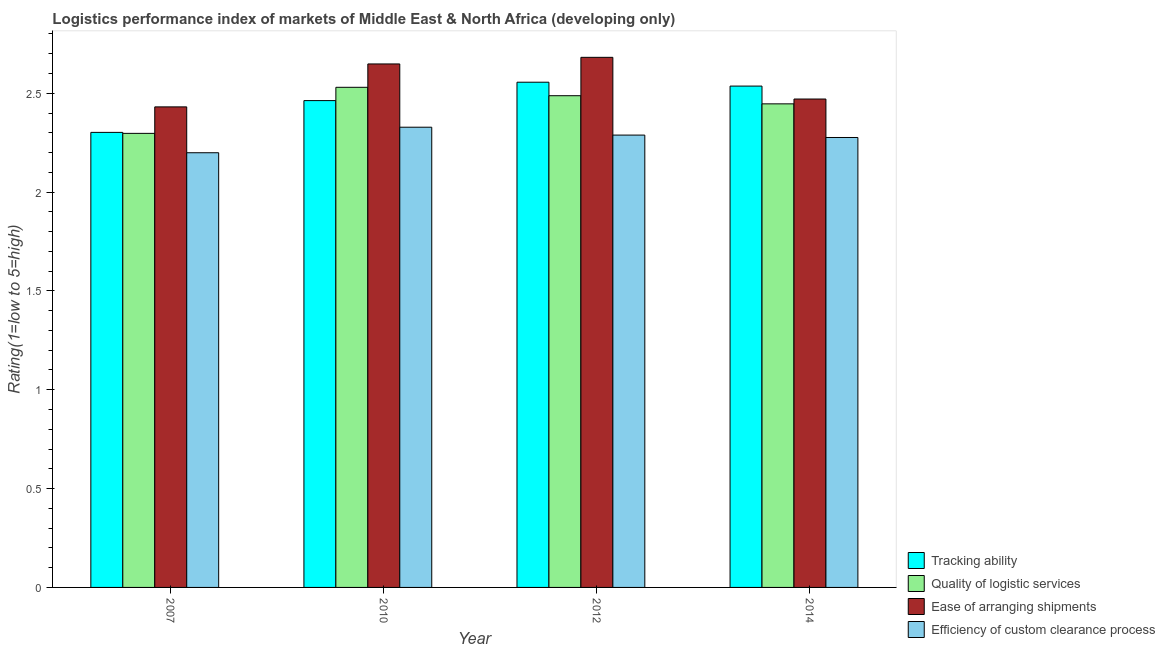How many different coloured bars are there?
Provide a succinct answer. 4. Are the number of bars per tick equal to the number of legend labels?
Provide a short and direct response. Yes. Are the number of bars on each tick of the X-axis equal?
Your response must be concise. Yes. In how many cases, is the number of bars for a given year not equal to the number of legend labels?
Your response must be concise. 0. What is the lpi rating of tracking ability in 2007?
Provide a succinct answer. 2.3. Across all years, what is the maximum lpi rating of efficiency of custom clearance process?
Keep it short and to the point. 2.33. Across all years, what is the minimum lpi rating of efficiency of custom clearance process?
Your response must be concise. 2.2. In which year was the lpi rating of efficiency of custom clearance process minimum?
Your response must be concise. 2007. What is the total lpi rating of ease of arranging shipments in the graph?
Provide a short and direct response. 10.23. What is the difference between the lpi rating of tracking ability in 2010 and that in 2014?
Your answer should be very brief. -0.07. What is the difference between the lpi rating of quality of logistic services in 2012 and the lpi rating of efficiency of custom clearance process in 2010?
Your answer should be very brief. -0.04. What is the average lpi rating of ease of arranging shipments per year?
Offer a very short reply. 2.56. In how many years, is the lpi rating of ease of arranging shipments greater than 0.7?
Your response must be concise. 4. What is the ratio of the lpi rating of quality of logistic services in 2007 to that in 2012?
Ensure brevity in your answer.  0.92. Is the lpi rating of tracking ability in 2012 less than that in 2014?
Provide a succinct answer. No. What is the difference between the highest and the second highest lpi rating of efficiency of custom clearance process?
Keep it short and to the point. 0.04. What is the difference between the highest and the lowest lpi rating of quality of logistic services?
Provide a short and direct response. 0.23. In how many years, is the lpi rating of ease of arranging shipments greater than the average lpi rating of ease of arranging shipments taken over all years?
Offer a very short reply. 2. Is the sum of the lpi rating of ease of arranging shipments in 2007 and 2010 greater than the maximum lpi rating of efficiency of custom clearance process across all years?
Offer a very short reply. Yes. What does the 3rd bar from the left in 2010 represents?
Your response must be concise. Ease of arranging shipments. What does the 3rd bar from the right in 2007 represents?
Offer a terse response. Quality of logistic services. How many bars are there?
Your answer should be very brief. 16. Are all the bars in the graph horizontal?
Your answer should be very brief. No. How many years are there in the graph?
Provide a short and direct response. 4. What is the difference between two consecutive major ticks on the Y-axis?
Ensure brevity in your answer.  0.5. Does the graph contain any zero values?
Your response must be concise. No. Does the graph contain grids?
Your response must be concise. No. How many legend labels are there?
Offer a terse response. 4. How are the legend labels stacked?
Ensure brevity in your answer.  Vertical. What is the title of the graph?
Keep it short and to the point. Logistics performance index of markets of Middle East & North Africa (developing only). Does "Secondary general" appear as one of the legend labels in the graph?
Make the answer very short. No. What is the label or title of the X-axis?
Offer a terse response. Year. What is the label or title of the Y-axis?
Offer a very short reply. Rating(1=low to 5=high). What is the Rating(1=low to 5=high) in Tracking ability in 2007?
Offer a terse response. 2.3. What is the Rating(1=low to 5=high) of Quality of logistic services in 2007?
Give a very brief answer. 2.3. What is the Rating(1=low to 5=high) in Ease of arranging shipments in 2007?
Ensure brevity in your answer.  2.43. What is the Rating(1=low to 5=high) of Efficiency of custom clearance process in 2007?
Offer a very short reply. 2.2. What is the Rating(1=low to 5=high) in Tracking ability in 2010?
Your response must be concise. 2.46. What is the Rating(1=low to 5=high) of Quality of logistic services in 2010?
Your answer should be very brief. 2.53. What is the Rating(1=low to 5=high) in Ease of arranging shipments in 2010?
Offer a very short reply. 2.65. What is the Rating(1=low to 5=high) in Efficiency of custom clearance process in 2010?
Your response must be concise. 2.33. What is the Rating(1=low to 5=high) in Tracking ability in 2012?
Your answer should be very brief. 2.56. What is the Rating(1=low to 5=high) of Quality of logistic services in 2012?
Offer a very short reply. 2.49. What is the Rating(1=low to 5=high) of Ease of arranging shipments in 2012?
Ensure brevity in your answer.  2.68. What is the Rating(1=low to 5=high) in Efficiency of custom clearance process in 2012?
Keep it short and to the point. 2.29. What is the Rating(1=low to 5=high) of Tracking ability in 2014?
Provide a succinct answer. 2.54. What is the Rating(1=low to 5=high) in Quality of logistic services in 2014?
Your response must be concise. 2.45. What is the Rating(1=low to 5=high) of Ease of arranging shipments in 2014?
Offer a terse response. 2.47. What is the Rating(1=low to 5=high) of Efficiency of custom clearance process in 2014?
Your answer should be very brief. 2.28. Across all years, what is the maximum Rating(1=low to 5=high) of Tracking ability?
Offer a very short reply. 2.56. Across all years, what is the maximum Rating(1=low to 5=high) in Quality of logistic services?
Your answer should be compact. 2.53. Across all years, what is the maximum Rating(1=low to 5=high) of Ease of arranging shipments?
Keep it short and to the point. 2.68. Across all years, what is the maximum Rating(1=low to 5=high) of Efficiency of custom clearance process?
Offer a terse response. 2.33. Across all years, what is the minimum Rating(1=low to 5=high) in Tracking ability?
Make the answer very short. 2.3. Across all years, what is the minimum Rating(1=low to 5=high) of Quality of logistic services?
Offer a terse response. 2.3. Across all years, what is the minimum Rating(1=low to 5=high) in Ease of arranging shipments?
Make the answer very short. 2.43. Across all years, what is the minimum Rating(1=low to 5=high) of Efficiency of custom clearance process?
Provide a short and direct response. 2.2. What is the total Rating(1=low to 5=high) in Tracking ability in the graph?
Give a very brief answer. 9.86. What is the total Rating(1=low to 5=high) in Quality of logistic services in the graph?
Keep it short and to the point. 9.76. What is the total Rating(1=low to 5=high) of Ease of arranging shipments in the graph?
Keep it short and to the point. 10.23. What is the total Rating(1=low to 5=high) of Efficiency of custom clearance process in the graph?
Provide a succinct answer. 9.09. What is the difference between the Rating(1=low to 5=high) of Tracking ability in 2007 and that in 2010?
Your response must be concise. -0.16. What is the difference between the Rating(1=low to 5=high) in Quality of logistic services in 2007 and that in 2010?
Provide a succinct answer. -0.23. What is the difference between the Rating(1=low to 5=high) of Ease of arranging shipments in 2007 and that in 2010?
Ensure brevity in your answer.  -0.22. What is the difference between the Rating(1=low to 5=high) of Efficiency of custom clearance process in 2007 and that in 2010?
Provide a succinct answer. -0.13. What is the difference between the Rating(1=low to 5=high) of Tracking ability in 2007 and that in 2012?
Provide a short and direct response. -0.25. What is the difference between the Rating(1=low to 5=high) in Quality of logistic services in 2007 and that in 2012?
Your answer should be very brief. -0.19. What is the difference between the Rating(1=low to 5=high) of Ease of arranging shipments in 2007 and that in 2012?
Your answer should be very brief. -0.25. What is the difference between the Rating(1=low to 5=high) of Efficiency of custom clearance process in 2007 and that in 2012?
Your response must be concise. -0.09. What is the difference between the Rating(1=low to 5=high) in Tracking ability in 2007 and that in 2014?
Your answer should be very brief. -0.23. What is the difference between the Rating(1=low to 5=high) of Quality of logistic services in 2007 and that in 2014?
Make the answer very short. -0.15. What is the difference between the Rating(1=low to 5=high) in Ease of arranging shipments in 2007 and that in 2014?
Keep it short and to the point. -0.04. What is the difference between the Rating(1=low to 5=high) in Efficiency of custom clearance process in 2007 and that in 2014?
Your response must be concise. -0.08. What is the difference between the Rating(1=low to 5=high) of Tracking ability in 2010 and that in 2012?
Keep it short and to the point. -0.09. What is the difference between the Rating(1=low to 5=high) of Quality of logistic services in 2010 and that in 2012?
Your response must be concise. 0.04. What is the difference between the Rating(1=low to 5=high) of Ease of arranging shipments in 2010 and that in 2012?
Give a very brief answer. -0.03. What is the difference between the Rating(1=low to 5=high) in Efficiency of custom clearance process in 2010 and that in 2012?
Give a very brief answer. 0.04. What is the difference between the Rating(1=low to 5=high) in Tracking ability in 2010 and that in 2014?
Your answer should be compact. -0.07. What is the difference between the Rating(1=low to 5=high) in Quality of logistic services in 2010 and that in 2014?
Offer a very short reply. 0.08. What is the difference between the Rating(1=low to 5=high) of Ease of arranging shipments in 2010 and that in 2014?
Provide a succinct answer. 0.18. What is the difference between the Rating(1=low to 5=high) in Efficiency of custom clearance process in 2010 and that in 2014?
Make the answer very short. 0.05. What is the difference between the Rating(1=low to 5=high) of Tracking ability in 2012 and that in 2014?
Make the answer very short. 0.02. What is the difference between the Rating(1=low to 5=high) of Quality of logistic services in 2012 and that in 2014?
Give a very brief answer. 0.04. What is the difference between the Rating(1=low to 5=high) of Ease of arranging shipments in 2012 and that in 2014?
Give a very brief answer. 0.21. What is the difference between the Rating(1=low to 5=high) in Efficiency of custom clearance process in 2012 and that in 2014?
Your answer should be compact. 0.01. What is the difference between the Rating(1=low to 5=high) of Tracking ability in 2007 and the Rating(1=low to 5=high) of Quality of logistic services in 2010?
Make the answer very short. -0.23. What is the difference between the Rating(1=low to 5=high) in Tracking ability in 2007 and the Rating(1=low to 5=high) in Ease of arranging shipments in 2010?
Offer a very short reply. -0.35. What is the difference between the Rating(1=low to 5=high) in Tracking ability in 2007 and the Rating(1=low to 5=high) in Efficiency of custom clearance process in 2010?
Give a very brief answer. -0.03. What is the difference between the Rating(1=low to 5=high) in Quality of logistic services in 2007 and the Rating(1=low to 5=high) in Ease of arranging shipments in 2010?
Offer a terse response. -0.35. What is the difference between the Rating(1=low to 5=high) of Quality of logistic services in 2007 and the Rating(1=low to 5=high) of Efficiency of custom clearance process in 2010?
Ensure brevity in your answer.  -0.03. What is the difference between the Rating(1=low to 5=high) in Ease of arranging shipments in 2007 and the Rating(1=low to 5=high) in Efficiency of custom clearance process in 2010?
Give a very brief answer. 0.1. What is the difference between the Rating(1=low to 5=high) of Tracking ability in 2007 and the Rating(1=low to 5=high) of Quality of logistic services in 2012?
Ensure brevity in your answer.  -0.19. What is the difference between the Rating(1=low to 5=high) in Tracking ability in 2007 and the Rating(1=low to 5=high) in Ease of arranging shipments in 2012?
Your answer should be compact. -0.38. What is the difference between the Rating(1=low to 5=high) in Tracking ability in 2007 and the Rating(1=low to 5=high) in Efficiency of custom clearance process in 2012?
Offer a terse response. 0.01. What is the difference between the Rating(1=low to 5=high) in Quality of logistic services in 2007 and the Rating(1=low to 5=high) in Ease of arranging shipments in 2012?
Keep it short and to the point. -0.38. What is the difference between the Rating(1=low to 5=high) in Quality of logistic services in 2007 and the Rating(1=low to 5=high) in Efficiency of custom clearance process in 2012?
Offer a terse response. 0.01. What is the difference between the Rating(1=low to 5=high) of Ease of arranging shipments in 2007 and the Rating(1=low to 5=high) of Efficiency of custom clearance process in 2012?
Provide a succinct answer. 0.14. What is the difference between the Rating(1=low to 5=high) of Tracking ability in 2007 and the Rating(1=low to 5=high) of Quality of logistic services in 2014?
Make the answer very short. -0.14. What is the difference between the Rating(1=low to 5=high) of Tracking ability in 2007 and the Rating(1=low to 5=high) of Ease of arranging shipments in 2014?
Offer a very short reply. -0.17. What is the difference between the Rating(1=low to 5=high) of Tracking ability in 2007 and the Rating(1=low to 5=high) of Efficiency of custom clearance process in 2014?
Your answer should be very brief. 0.03. What is the difference between the Rating(1=low to 5=high) in Quality of logistic services in 2007 and the Rating(1=low to 5=high) in Ease of arranging shipments in 2014?
Your answer should be very brief. -0.17. What is the difference between the Rating(1=low to 5=high) in Quality of logistic services in 2007 and the Rating(1=low to 5=high) in Efficiency of custom clearance process in 2014?
Offer a terse response. 0.02. What is the difference between the Rating(1=low to 5=high) of Ease of arranging shipments in 2007 and the Rating(1=low to 5=high) of Efficiency of custom clearance process in 2014?
Give a very brief answer. 0.15. What is the difference between the Rating(1=low to 5=high) of Tracking ability in 2010 and the Rating(1=low to 5=high) of Quality of logistic services in 2012?
Make the answer very short. -0.02. What is the difference between the Rating(1=low to 5=high) in Tracking ability in 2010 and the Rating(1=low to 5=high) in Ease of arranging shipments in 2012?
Offer a very short reply. -0.22. What is the difference between the Rating(1=low to 5=high) of Tracking ability in 2010 and the Rating(1=low to 5=high) of Efficiency of custom clearance process in 2012?
Your answer should be very brief. 0.17. What is the difference between the Rating(1=low to 5=high) of Quality of logistic services in 2010 and the Rating(1=low to 5=high) of Ease of arranging shipments in 2012?
Give a very brief answer. -0.15. What is the difference between the Rating(1=low to 5=high) of Quality of logistic services in 2010 and the Rating(1=low to 5=high) of Efficiency of custom clearance process in 2012?
Provide a succinct answer. 0.24. What is the difference between the Rating(1=low to 5=high) of Ease of arranging shipments in 2010 and the Rating(1=low to 5=high) of Efficiency of custom clearance process in 2012?
Keep it short and to the point. 0.36. What is the difference between the Rating(1=low to 5=high) of Tracking ability in 2010 and the Rating(1=low to 5=high) of Quality of logistic services in 2014?
Your answer should be very brief. 0.02. What is the difference between the Rating(1=low to 5=high) of Tracking ability in 2010 and the Rating(1=low to 5=high) of Ease of arranging shipments in 2014?
Provide a succinct answer. -0.01. What is the difference between the Rating(1=low to 5=high) of Tracking ability in 2010 and the Rating(1=low to 5=high) of Efficiency of custom clearance process in 2014?
Offer a very short reply. 0.19. What is the difference between the Rating(1=low to 5=high) in Quality of logistic services in 2010 and the Rating(1=low to 5=high) in Ease of arranging shipments in 2014?
Keep it short and to the point. 0.06. What is the difference between the Rating(1=low to 5=high) in Quality of logistic services in 2010 and the Rating(1=low to 5=high) in Efficiency of custom clearance process in 2014?
Ensure brevity in your answer.  0.25. What is the difference between the Rating(1=low to 5=high) of Ease of arranging shipments in 2010 and the Rating(1=low to 5=high) of Efficiency of custom clearance process in 2014?
Make the answer very short. 0.37. What is the difference between the Rating(1=low to 5=high) in Tracking ability in 2012 and the Rating(1=low to 5=high) in Quality of logistic services in 2014?
Give a very brief answer. 0.11. What is the difference between the Rating(1=low to 5=high) of Tracking ability in 2012 and the Rating(1=low to 5=high) of Ease of arranging shipments in 2014?
Your answer should be compact. 0.09. What is the difference between the Rating(1=low to 5=high) of Tracking ability in 2012 and the Rating(1=low to 5=high) of Efficiency of custom clearance process in 2014?
Offer a very short reply. 0.28. What is the difference between the Rating(1=low to 5=high) in Quality of logistic services in 2012 and the Rating(1=low to 5=high) in Ease of arranging shipments in 2014?
Make the answer very short. 0.02. What is the difference between the Rating(1=low to 5=high) in Quality of logistic services in 2012 and the Rating(1=low to 5=high) in Efficiency of custom clearance process in 2014?
Make the answer very short. 0.21. What is the difference between the Rating(1=low to 5=high) of Ease of arranging shipments in 2012 and the Rating(1=low to 5=high) of Efficiency of custom clearance process in 2014?
Make the answer very short. 0.41. What is the average Rating(1=low to 5=high) of Tracking ability per year?
Offer a terse response. 2.46. What is the average Rating(1=low to 5=high) in Quality of logistic services per year?
Your answer should be compact. 2.44. What is the average Rating(1=low to 5=high) of Ease of arranging shipments per year?
Provide a short and direct response. 2.56. What is the average Rating(1=low to 5=high) of Efficiency of custom clearance process per year?
Provide a short and direct response. 2.27. In the year 2007, what is the difference between the Rating(1=low to 5=high) in Tracking ability and Rating(1=low to 5=high) in Quality of logistic services?
Offer a very short reply. 0.01. In the year 2007, what is the difference between the Rating(1=low to 5=high) in Tracking ability and Rating(1=low to 5=high) in Ease of arranging shipments?
Your response must be concise. -0.13. In the year 2007, what is the difference between the Rating(1=low to 5=high) in Tracking ability and Rating(1=low to 5=high) in Efficiency of custom clearance process?
Ensure brevity in your answer.  0.1. In the year 2007, what is the difference between the Rating(1=low to 5=high) of Quality of logistic services and Rating(1=low to 5=high) of Ease of arranging shipments?
Provide a succinct answer. -0.13. In the year 2007, what is the difference between the Rating(1=low to 5=high) of Quality of logistic services and Rating(1=low to 5=high) of Efficiency of custom clearance process?
Your answer should be compact. 0.1. In the year 2007, what is the difference between the Rating(1=low to 5=high) in Ease of arranging shipments and Rating(1=low to 5=high) in Efficiency of custom clearance process?
Offer a terse response. 0.23. In the year 2010, what is the difference between the Rating(1=low to 5=high) in Tracking ability and Rating(1=low to 5=high) in Quality of logistic services?
Give a very brief answer. -0.07. In the year 2010, what is the difference between the Rating(1=low to 5=high) in Tracking ability and Rating(1=low to 5=high) in Ease of arranging shipments?
Make the answer very short. -0.19. In the year 2010, what is the difference between the Rating(1=low to 5=high) of Tracking ability and Rating(1=low to 5=high) of Efficiency of custom clearance process?
Provide a short and direct response. 0.13. In the year 2010, what is the difference between the Rating(1=low to 5=high) in Quality of logistic services and Rating(1=low to 5=high) in Ease of arranging shipments?
Ensure brevity in your answer.  -0.12. In the year 2010, what is the difference between the Rating(1=low to 5=high) in Quality of logistic services and Rating(1=low to 5=high) in Efficiency of custom clearance process?
Your answer should be compact. 0.2. In the year 2010, what is the difference between the Rating(1=low to 5=high) of Ease of arranging shipments and Rating(1=low to 5=high) of Efficiency of custom clearance process?
Make the answer very short. 0.32. In the year 2012, what is the difference between the Rating(1=low to 5=high) of Tracking ability and Rating(1=low to 5=high) of Quality of logistic services?
Keep it short and to the point. 0.07. In the year 2012, what is the difference between the Rating(1=low to 5=high) of Tracking ability and Rating(1=low to 5=high) of Ease of arranging shipments?
Keep it short and to the point. -0.13. In the year 2012, what is the difference between the Rating(1=low to 5=high) of Tracking ability and Rating(1=low to 5=high) of Efficiency of custom clearance process?
Give a very brief answer. 0.27. In the year 2012, what is the difference between the Rating(1=low to 5=high) in Quality of logistic services and Rating(1=low to 5=high) in Ease of arranging shipments?
Ensure brevity in your answer.  -0.19. In the year 2012, what is the difference between the Rating(1=low to 5=high) in Quality of logistic services and Rating(1=low to 5=high) in Efficiency of custom clearance process?
Give a very brief answer. 0.2. In the year 2012, what is the difference between the Rating(1=low to 5=high) of Ease of arranging shipments and Rating(1=low to 5=high) of Efficiency of custom clearance process?
Your answer should be very brief. 0.39. In the year 2014, what is the difference between the Rating(1=low to 5=high) in Tracking ability and Rating(1=low to 5=high) in Quality of logistic services?
Offer a terse response. 0.09. In the year 2014, what is the difference between the Rating(1=low to 5=high) of Tracking ability and Rating(1=low to 5=high) of Ease of arranging shipments?
Your response must be concise. 0.07. In the year 2014, what is the difference between the Rating(1=low to 5=high) in Tracking ability and Rating(1=low to 5=high) in Efficiency of custom clearance process?
Offer a very short reply. 0.26. In the year 2014, what is the difference between the Rating(1=low to 5=high) of Quality of logistic services and Rating(1=low to 5=high) of Ease of arranging shipments?
Provide a succinct answer. -0.02. In the year 2014, what is the difference between the Rating(1=low to 5=high) in Quality of logistic services and Rating(1=low to 5=high) in Efficiency of custom clearance process?
Your answer should be very brief. 0.17. In the year 2014, what is the difference between the Rating(1=low to 5=high) in Ease of arranging shipments and Rating(1=low to 5=high) in Efficiency of custom clearance process?
Ensure brevity in your answer.  0.19. What is the ratio of the Rating(1=low to 5=high) of Tracking ability in 2007 to that in 2010?
Make the answer very short. 0.93. What is the ratio of the Rating(1=low to 5=high) of Quality of logistic services in 2007 to that in 2010?
Offer a very short reply. 0.91. What is the ratio of the Rating(1=low to 5=high) in Ease of arranging shipments in 2007 to that in 2010?
Give a very brief answer. 0.92. What is the ratio of the Rating(1=low to 5=high) in Efficiency of custom clearance process in 2007 to that in 2010?
Ensure brevity in your answer.  0.94. What is the ratio of the Rating(1=low to 5=high) of Tracking ability in 2007 to that in 2012?
Your response must be concise. 0.9. What is the ratio of the Rating(1=low to 5=high) in Quality of logistic services in 2007 to that in 2012?
Your answer should be compact. 0.92. What is the ratio of the Rating(1=low to 5=high) of Ease of arranging shipments in 2007 to that in 2012?
Ensure brevity in your answer.  0.91. What is the ratio of the Rating(1=low to 5=high) in Efficiency of custom clearance process in 2007 to that in 2012?
Your answer should be very brief. 0.96. What is the ratio of the Rating(1=low to 5=high) in Tracking ability in 2007 to that in 2014?
Provide a short and direct response. 0.91. What is the ratio of the Rating(1=low to 5=high) in Quality of logistic services in 2007 to that in 2014?
Give a very brief answer. 0.94. What is the ratio of the Rating(1=low to 5=high) of Ease of arranging shipments in 2007 to that in 2014?
Your response must be concise. 0.98. What is the ratio of the Rating(1=low to 5=high) of Efficiency of custom clearance process in 2007 to that in 2014?
Give a very brief answer. 0.97. What is the ratio of the Rating(1=low to 5=high) of Tracking ability in 2010 to that in 2012?
Offer a very short reply. 0.96. What is the ratio of the Rating(1=low to 5=high) of Quality of logistic services in 2010 to that in 2012?
Provide a succinct answer. 1.02. What is the ratio of the Rating(1=low to 5=high) of Ease of arranging shipments in 2010 to that in 2012?
Offer a terse response. 0.99. What is the ratio of the Rating(1=low to 5=high) in Efficiency of custom clearance process in 2010 to that in 2012?
Offer a very short reply. 1.02. What is the ratio of the Rating(1=low to 5=high) of Tracking ability in 2010 to that in 2014?
Make the answer very short. 0.97. What is the ratio of the Rating(1=low to 5=high) of Quality of logistic services in 2010 to that in 2014?
Make the answer very short. 1.03. What is the ratio of the Rating(1=low to 5=high) in Ease of arranging shipments in 2010 to that in 2014?
Keep it short and to the point. 1.07. What is the ratio of the Rating(1=low to 5=high) in Efficiency of custom clearance process in 2010 to that in 2014?
Offer a very short reply. 1.02. What is the ratio of the Rating(1=low to 5=high) of Tracking ability in 2012 to that in 2014?
Make the answer very short. 1.01. What is the ratio of the Rating(1=low to 5=high) in Quality of logistic services in 2012 to that in 2014?
Your response must be concise. 1.02. What is the ratio of the Rating(1=low to 5=high) of Ease of arranging shipments in 2012 to that in 2014?
Make the answer very short. 1.09. What is the difference between the highest and the second highest Rating(1=low to 5=high) of Tracking ability?
Make the answer very short. 0.02. What is the difference between the highest and the second highest Rating(1=low to 5=high) in Quality of logistic services?
Keep it short and to the point. 0.04. What is the difference between the highest and the second highest Rating(1=low to 5=high) of Ease of arranging shipments?
Keep it short and to the point. 0.03. What is the difference between the highest and the second highest Rating(1=low to 5=high) in Efficiency of custom clearance process?
Offer a terse response. 0.04. What is the difference between the highest and the lowest Rating(1=low to 5=high) in Tracking ability?
Offer a very short reply. 0.25. What is the difference between the highest and the lowest Rating(1=low to 5=high) of Quality of logistic services?
Give a very brief answer. 0.23. What is the difference between the highest and the lowest Rating(1=low to 5=high) of Ease of arranging shipments?
Offer a terse response. 0.25. What is the difference between the highest and the lowest Rating(1=low to 5=high) of Efficiency of custom clearance process?
Your response must be concise. 0.13. 